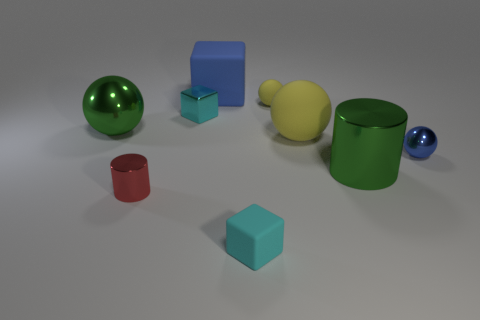Subtract all rubber cubes. How many cubes are left? 1 Subtract all red cylinders. How many cylinders are left? 1 Subtract all spheres. How many objects are left? 5 Add 1 small cyan rubber objects. How many objects exist? 10 Subtract 1 cylinders. How many cylinders are left? 1 Subtract all gray balls. How many gray cylinders are left? 0 Subtract all balls. Subtract all small green metal cubes. How many objects are left? 5 Add 7 tiny blue metal objects. How many tiny blue metal objects are left? 8 Add 2 small blue things. How many small blue things exist? 3 Subtract 0 gray blocks. How many objects are left? 9 